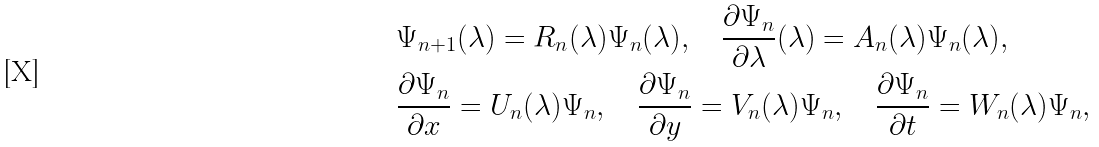<formula> <loc_0><loc_0><loc_500><loc_500>& \Psi _ { n + 1 } ( \lambda ) = R _ { n } ( \lambda ) \Psi _ { n } ( \lambda ) , \quad \frac { \partial \Psi _ { n } } { \partial \lambda } ( \lambda ) = A _ { n } ( \lambda ) \Psi _ { n } ( \lambda ) , \\ & \frac { \partial \Psi _ { n } } { \partial x } = U _ { n } ( \lambda ) \Psi _ { n } , \quad \frac { \partial \Psi _ { n } } { \partial y } = V _ { n } ( \lambda ) \Psi _ { n } , \quad \frac { \partial \Psi _ { n } } { \partial t } = W _ { n } ( \lambda ) \Psi _ { n } ,</formula> 